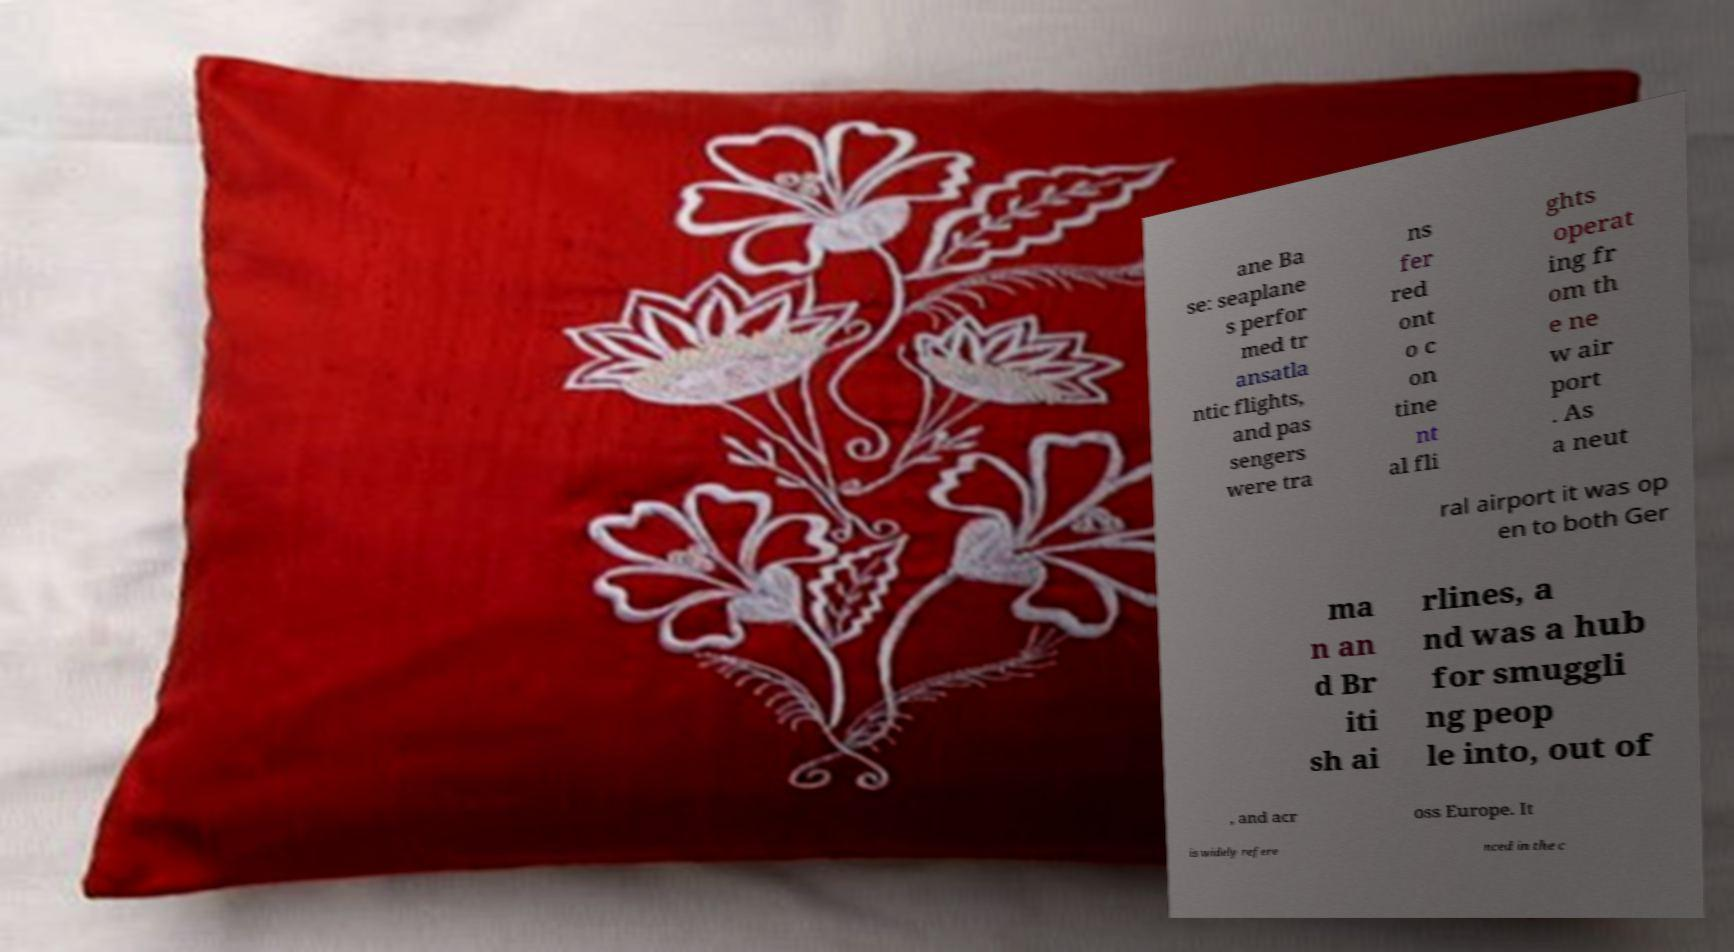Can you read and provide the text displayed in the image?This photo seems to have some interesting text. Can you extract and type it out for me? ane Ba se: seaplane s perfor med tr ansatla ntic flights, and pas sengers were tra ns fer red ont o c on tine nt al fli ghts operat ing fr om th e ne w air port . As a neut ral airport it was op en to both Ger ma n an d Br iti sh ai rlines, a nd was a hub for smuggli ng peop le into, out of , and acr oss Europe. It is widely refere nced in the c 